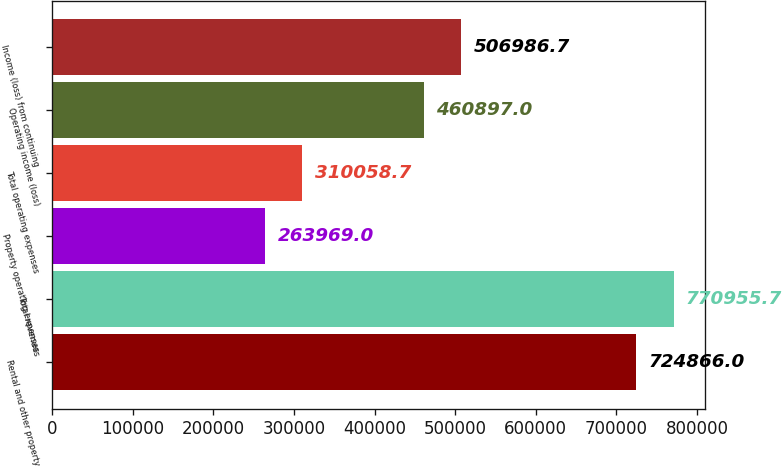Convert chart. <chart><loc_0><loc_0><loc_500><loc_500><bar_chart><fcel>Rental and other property<fcel>Total revenues<fcel>Property operating expenses<fcel>Total operating expenses<fcel>Operating income (loss)<fcel>Income (loss) from continuing<nl><fcel>724866<fcel>770956<fcel>263969<fcel>310059<fcel>460897<fcel>506987<nl></chart> 